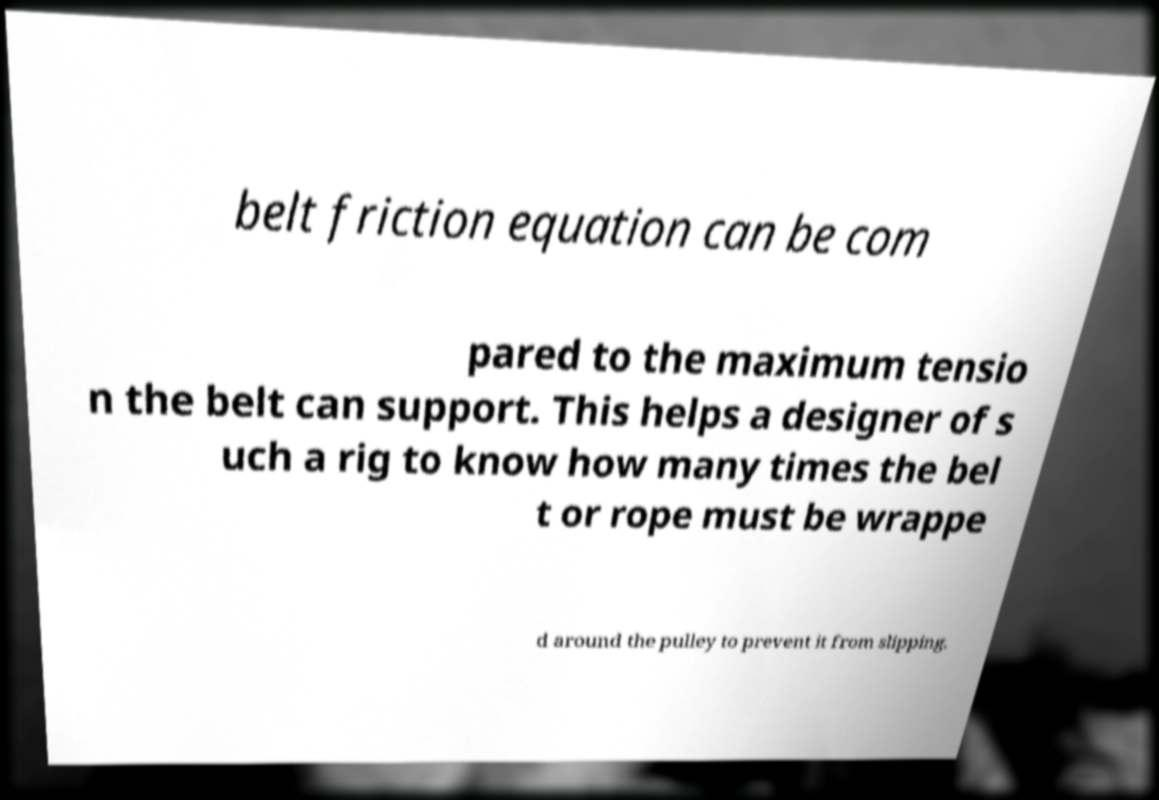Can you read and provide the text displayed in the image?This photo seems to have some interesting text. Can you extract and type it out for me? belt friction equation can be com pared to the maximum tensio n the belt can support. This helps a designer of s uch a rig to know how many times the bel t or rope must be wrappe d around the pulley to prevent it from slipping. 